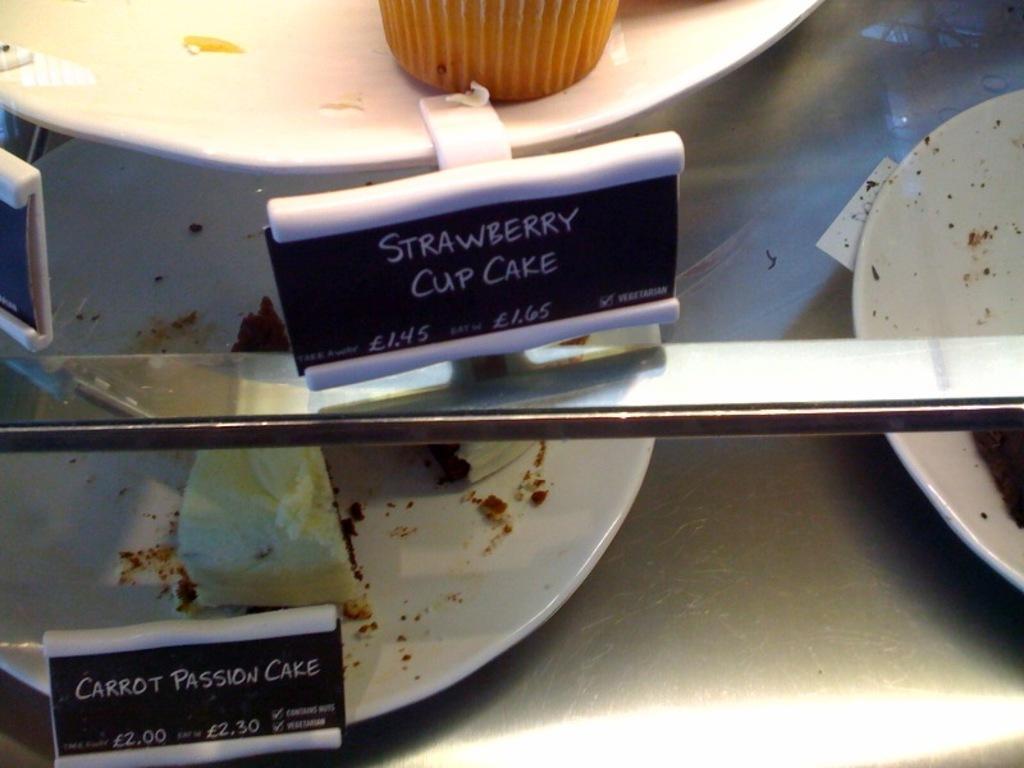How would you summarize this image in a sentence or two? In this picture we can see boards and plate with muffin on the glass platform, under the glass platform we can see plates with cakes and board on the platform. 